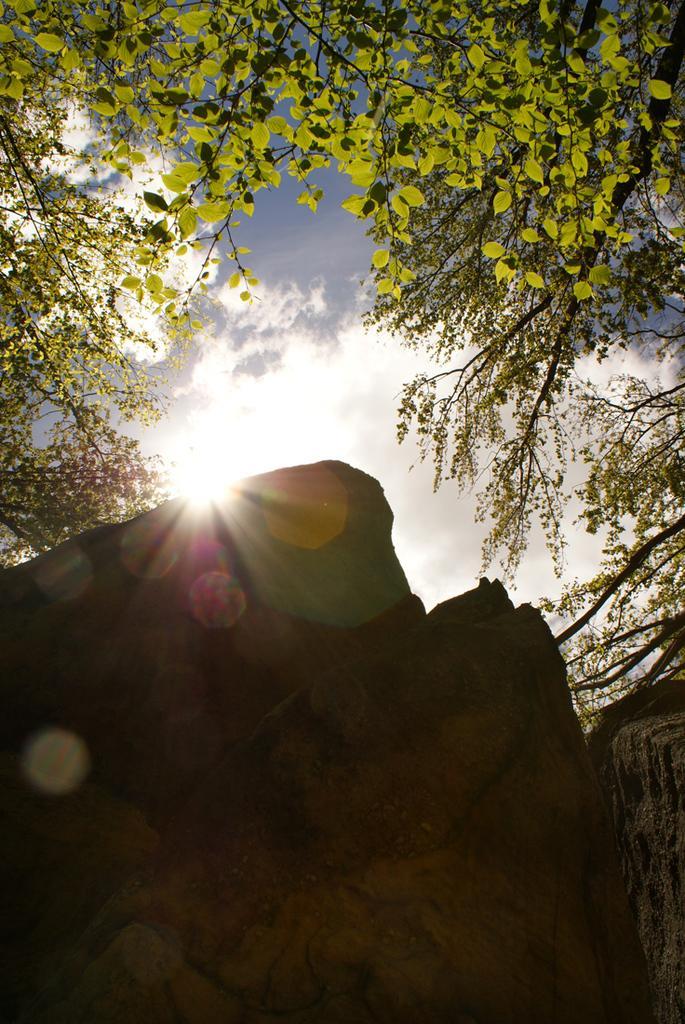In one or two sentences, can you explain what this image depicts? This image is taken outdoors. At the bottom of the image there are a few rocks. In the middle of the image there is the sky with clouds and sun. On the left and right sides of the image there are a few trees with leaves, stems and branches. 